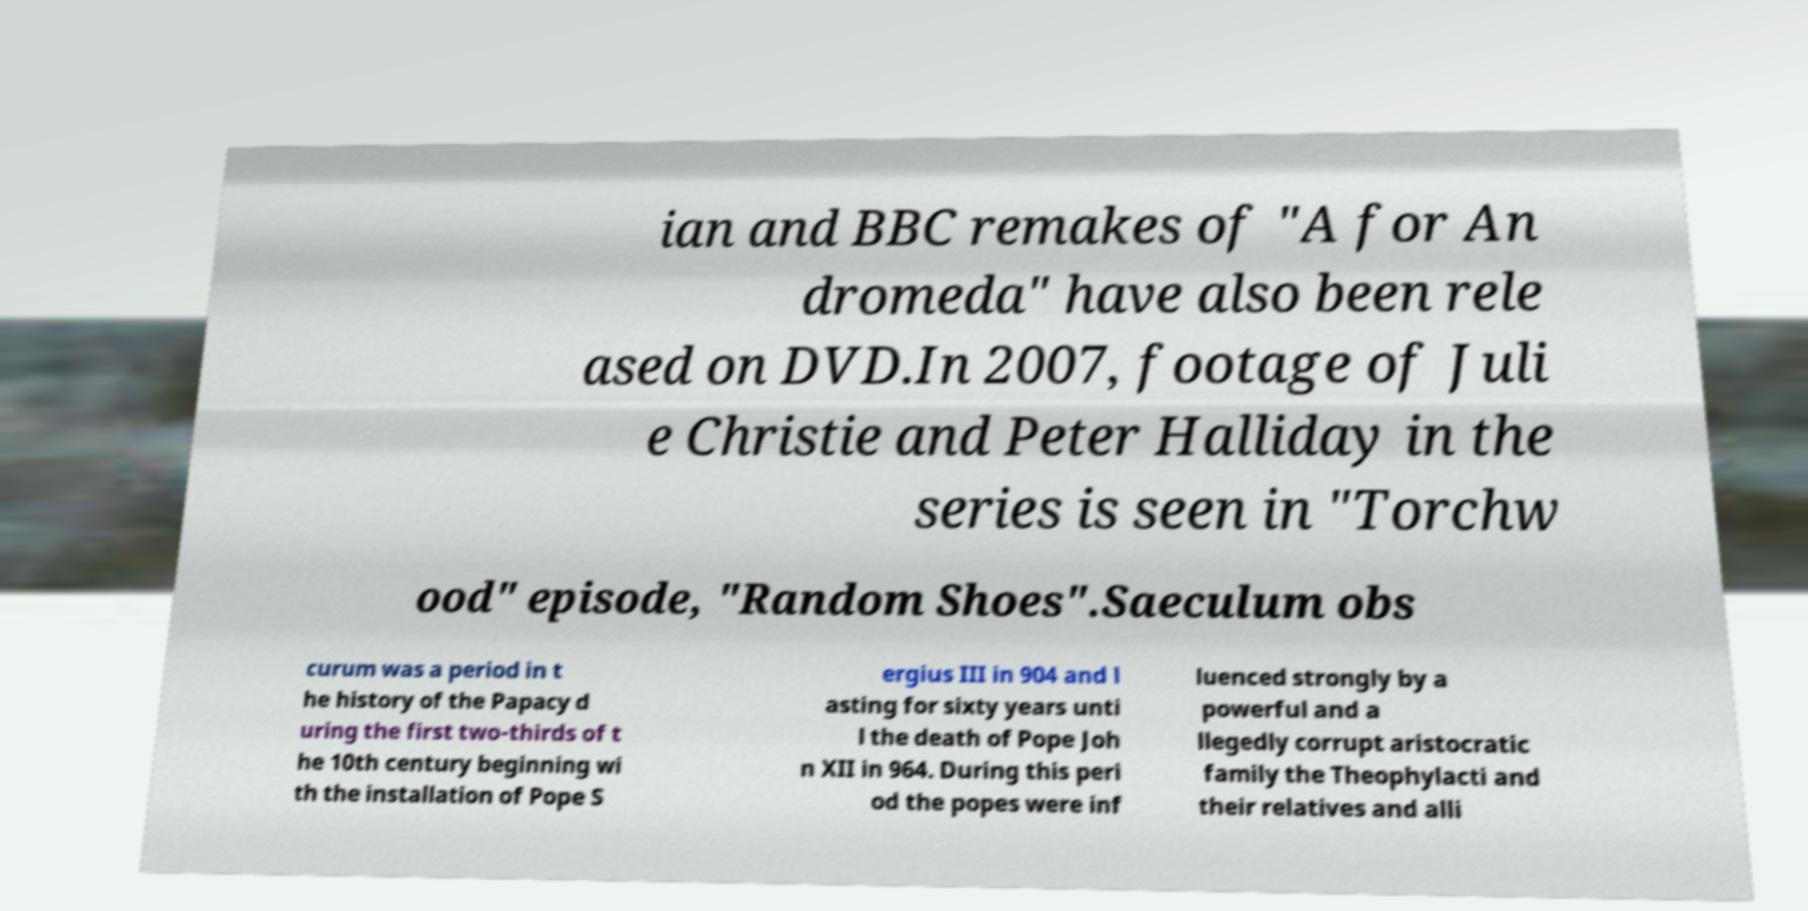Please read and relay the text visible in this image. What does it say? ian and BBC remakes of "A for An dromeda" have also been rele ased on DVD.In 2007, footage of Juli e Christie and Peter Halliday in the series is seen in "Torchw ood" episode, "Random Shoes".Saeculum obs curum was a period in t he history of the Papacy d uring the first two-thirds of t he 10th century beginning wi th the installation of Pope S ergius III in 904 and l asting for sixty years unti l the death of Pope Joh n XII in 964. During this peri od the popes were inf luenced strongly by a powerful and a llegedly corrupt aristocratic family the Theophylacti and their relatives and alli 